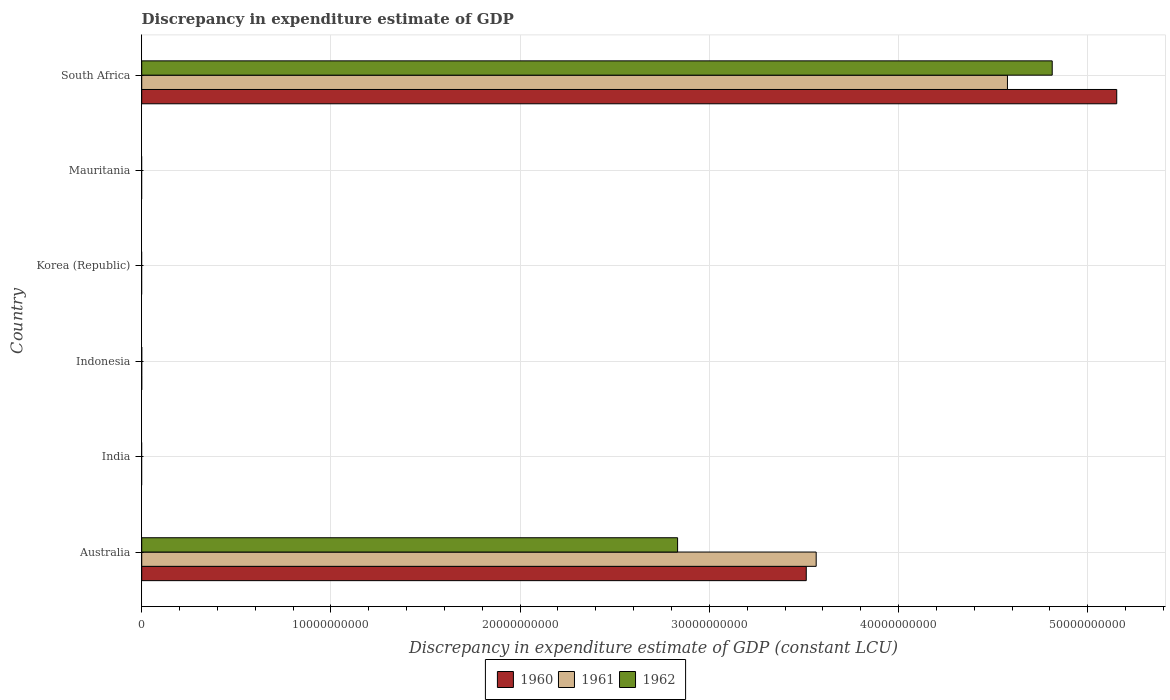Are the number of bars per tick equal to the number of legend labels?
Ensure brevity in your answer.  No. Are the number of bars on each tick of the Y-axis equal?
Your answer should be very brief. No. How many bars are there on the 1st tick from the bottom?
Offer a terse response. 3. What is the label of the 6th group of bars from the top?
Offer a terse response. Australia. What is the discrepancy in expenditure estimate of GDP in 1962 in Australia?
Provide a succinct answer. 2.83e+1. Across all countries, what is the maximum discrepancy in expenditure estimate of GDP in 1960?
Offer a terse response. 5.15e+1. Across all countries, what is the minimum discrepancy in expenditure estimate of GDP in 1961?
Make the answer very short. 0. In which country was the discrepancy in expenditure estimate of GDP in 1961 maximum?
Give a very brief answer. South Africa. What is the total discrepancy in expenditure estimate of GDP in 1962 in the graph?
Provide a short and direct response. 7.64e+1. What is the difference between the discrepancy in expenditure estimate of GDP in 1960 in South Africa and the discrepancy in expenditure estimate of GDP in 1962 in Mauritania?
Make the answer very short. 5.15e+1. What is the average discrepancy in expenditure estimate of GDP in 1962 per country?
Give a very brief answer. 1.27e+1. What is the difference between the discrepancy in expenditure estimate of GDP in 1960 and discrepancy in expenditure estimate of GDP in 1961 in South Africa?
Provide a short and direct response. 5.78e+09. In how many countries, is the discrepancy in expenditure estimate of GDP in 1962 greater than 4000000000 LCU?
Ensure brevity in your answer.  2. What is the difference between the highest and the lowest discrepancy in expenditure estimate of GDP in 1960?
Give a very brief answer. 5.15e+1. How many bars are there?
Keep it short and to the point. 6. Are all the bars in the graph horizontal?
Keep it short and to the point. Yes. What is the difference between two consecutive major ticks on the X-axis?
Provide a short and direct response. 1.00e+1. Are the values on the major ticks of X-axis written in scientific E-notation?
Give a very brief answer. No. Does the graph contain grids?
Provide a short and direct response. Yes. How many legend labels are there?
Offer a very short reply. 3. What is the title of the graph?
Give a very brief answer. Discrepancy in expenditure estimate of GDP. Does "1974" appear as one of the legend labels in the graph?
Your response must be concise. No. What is the label or title of the X-axis?
Offer a terse response. Discrepancy in expenditure estimate of GDP (constant LCU). What is the label or title of the Y-axis?
Keep it short and to the point. Country. What is the Discrepancy in expenditure estimate of GDP (constant LCU) in 1960 in Australia?
Offer a terse response. 3.51e+1. What is the Discrepancy in expenditure estimate of GDP (constant LCU) in 1961 in Australia?
Your response must be concise. 3.56e+1. What is the Discrepancy in expenditure estimate of GDP (constant LCU) of 1962 in Australia?
Offer a very short reply. 2.83e+1. What is the Discrepancy in expenditure estimate of GDP (constant LCU) of 1960 in Indonesia?
Your answer should be compact. 0. What is the Discrepancy in expenditure estimate of GDP (constant LCU) in 1962 in Indonesia?
Provide a succinct answer. 0. What is the Discrepancy in expenditure estimate of GDP (constant LCU) in 1960 in Korea (Republic)?
Offer a terse response. 0. What is the Discrepancy in expenditure estimate of GDP (constant LCU) in 1960 in Mauritania?
Provide a short and direct response. 0. What is the Discrepancy in expenditure estimate of GDP (constant LCU) of 1962 in Mauritania?
Make the answer very short. 0. What is the Discrepancy in expenditure estimate of GDP (constant LCU) in 1960 in South Africa?
Offer a terse response. 5.15e+1. What is the Discrepancy in expenditure estimate of GDP (constant LCU) in 1961 in South Africa?
Make the answer very short. 4.58e+1. What is the Discrepancy in expenditure estimate of GDP (constant LCU) of 1962 in South Africa?
Ensure brevity in your answer.  4.81e+1. Across all countries, what is the maximum Discrepancy in expenditure estimate of GDP (constant LCU) in 1960?
Make the answer very short. 5.15e+1. Across all countries, what is the maximum Discrepancy in expenditure estimate of GDP (constant LCU) of 1961?
Provide a short and direct response. 4.58e+1. Across all countries, what is the maximum Discrepancy in expenditure estimate of GDP (constant LCU) in 1962?
Provide a short and direct response. 4.81e+1. Across all countries, what is the minimum Discrepancy in expenditure estimate of GDP (constant LCU) of 1960?
Give a very brief answer. 0. Across all countries, what is the minimum Discrepancy in expenditure estimate of GDP (constant LCU) of 1962?
Offer a terse response. 0. What is the total Discrepancy in expenditure estimate of GDP (constant LCU) in 1960 in the graph?
Give a very brief answer. 8.67e+1. What is the total Discrepancy in expenditure estimate of GDP (constant LCU) of 1961 in the graph?
Offer a terse response. 8.14e+1. What is the total Discrepancy in expenditure estimate of GDP (constant LCU) in 1962 in the graph?
Ensure brevity in your answer.  7.64e+1. What is the difference between the Discrepancy in expenditure estimate of GDP (constant LCU) of 1960 in Australia and that in South Africa?
Your answer should be compact. -1.64e+1. What is the difference between the Discrepancy in expenditure estimate of GDP (constant LCU) of 1961 in Australia and that in South Africa?
Give a very brief answer. -1.01e+1. What is the difference between the Discrepancy in expenditure estimate of GDP (constant LCU) in 1962 in Australia and that in South Africa?
Keep it short and to the point. -1.98e+1. What is the difference between the Discrepancy in expenditure estimate of GDP (constant LCU) in 1960 in Australia and the Discrepancy in expenditure estimate of GDP (constant LCU) in 1961 in South Africa?
Offer a very short reply. -1.06e+1. What is the difference between the Discrepancy in expenditure estimate of GDP (constant LCU) of 1960 in Australia and the Discrepancy in expenditure estimate of GDP (constant LCU) of 1962 in South Africa?
Give a very brief answer. -1.30e+1. What is the difference between the Discrepancy in expenditure estimate of GDP (constant LCU) in 1961 in Australia and the Discrepancy in expenditure estimate of GDP (constant LCU) in 1962 in South Africa?
Offer a terse response. -1.25e+1. What is the average Discrepancy in expenditure estimate of GDP (constant LCU) of 1960 per country?
Ensure brevity in your answer.  1.44e+1. What is the average Discrepancy in expenditure estimate of GDP (constant LCU) in 1961 per country?
Provide a short and direct response. 1.36e+1. What is the average Discrepancy in expenditure estimate of GDP (constant LCU) in 1962 per country?
Provide a succinct answer. 1.27e+1. What is the difference between the Discrepancy in expenditure estimate of GDP (constant LCU) in 1960 and Discrepancy in expenditure estimate of GDP (constant LCU) in 1961 in Australia?
Make the answer very short. -5.25e+08. What is the difference between the Discrepancy in expenditure estimate of GDP (constant LCU) in 1960 and Discrepancy in expenditure estimate of GDP (constant LCU) in 1962 in Australia?
Offer a very short reply. 6.80e+09. What is the difference between the Discrepancy in expenditure estimate of GDP (constant LCU) of 1961 and Discrepancy in expenditure estimate of GDP (constant LCU) of 1962 in Australia?
Your response must be concise. 7.33e+09. What is the difference between the Discrepancy in expenditure estimate of GDP (constant LCU) of 1960 and Discrepancy in expenditure estimate of GDP (constant LCU) of 1961 in South Africa?
Provide a succinct answer. 5.78e+09. What is the difference between the Discrepancy in expenditure estimate of GDP (constant LCU) in 1960 and Discrepancy in expenditure estimate of GDP (constant LCU) in 1962 in South Africa?
Offer a very short reply. 3.41e+09. What is the difference between the Discrepancy in expenditure estimate of GDP (constant LCU) of 1961 and Discrepancy in expenditure estimate of GDP (constant LCU) of 1962 in South Africa?
Keep it short and to the point. -2.37e+09. What is the ratio of the Discrepancy in expenditure estimate of GDP (constant LCU) in 1960 in Australia to that in South Africa?
Your response must be concise. 0.68. What is the ratio of the Discrepancy in expenditure estimate of GDP (constant LCU) in 1961 in Australia to that in South Africa?
Provide a succinct answer. 0.78. What is the ratio of the Discrepancy in expenditure estimate of GDP (constant LCU) of 1962 in Australia to that in South Africa?
Your answer should be very brief. 0.59. What is the difference between the highest and the lowest Discrepancy in expenditure estimate of GDP (constant LCU) of 1960?
Make the answer very short. 5.15e+1. What is the difference between the highest and the lowest Discrepancy in expenditure estimate of GDP (constant LCU) in 1961?
Your answer should be compact. 4.58e+1. What is the difference between the highest and the lowest Discrepancy in expenditure estimate of GDP (constant LCU) in 1962?
Make the answer very short. 4.81e+1. 